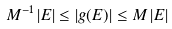<formula> <loc_0><loc_0><loc_500><loc_500>M ^ { - 1 } \, | E | \leq | g ( E ) | \leq M \, | E |</formula> 